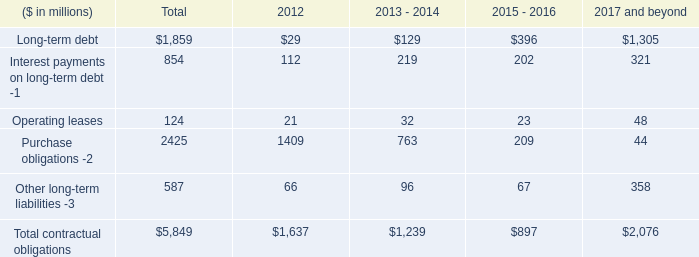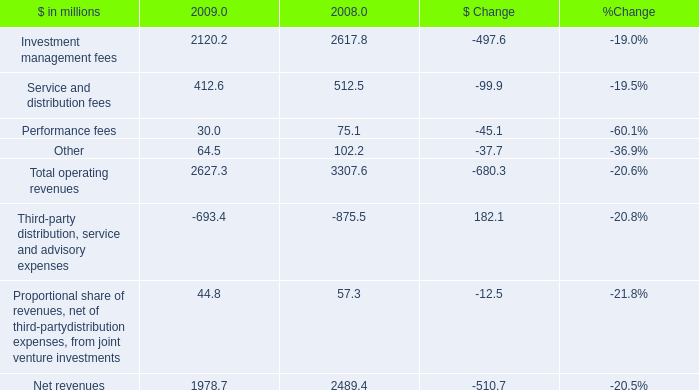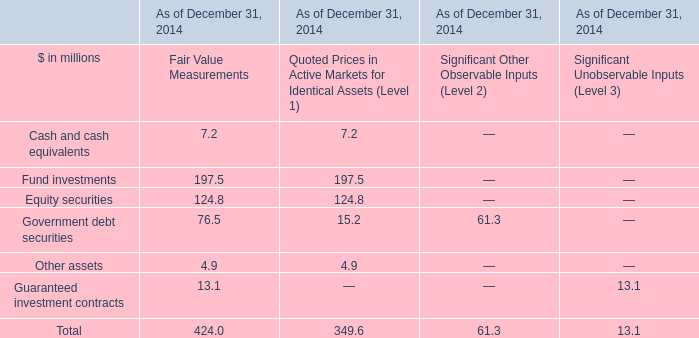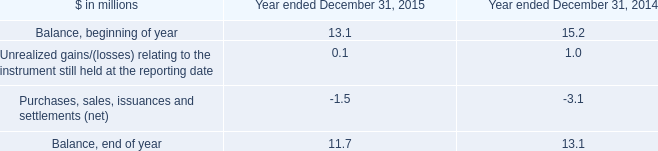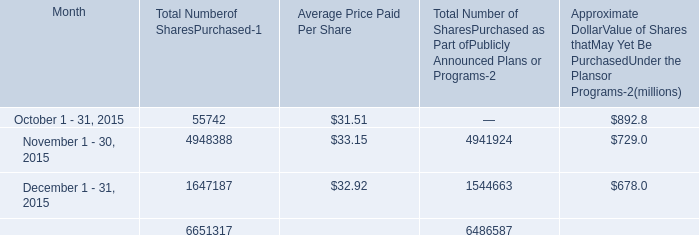In the section with lowest amount of Approximate DollarValue of Shares thatMay Yet Be PurchasedUnder the Plansor Programs-, what's the increasing rate of Average Price Paid Per Share? (in %) 
Computations: ((32.92 - 33.15) / 33.15)
Answer: -0.00694. 